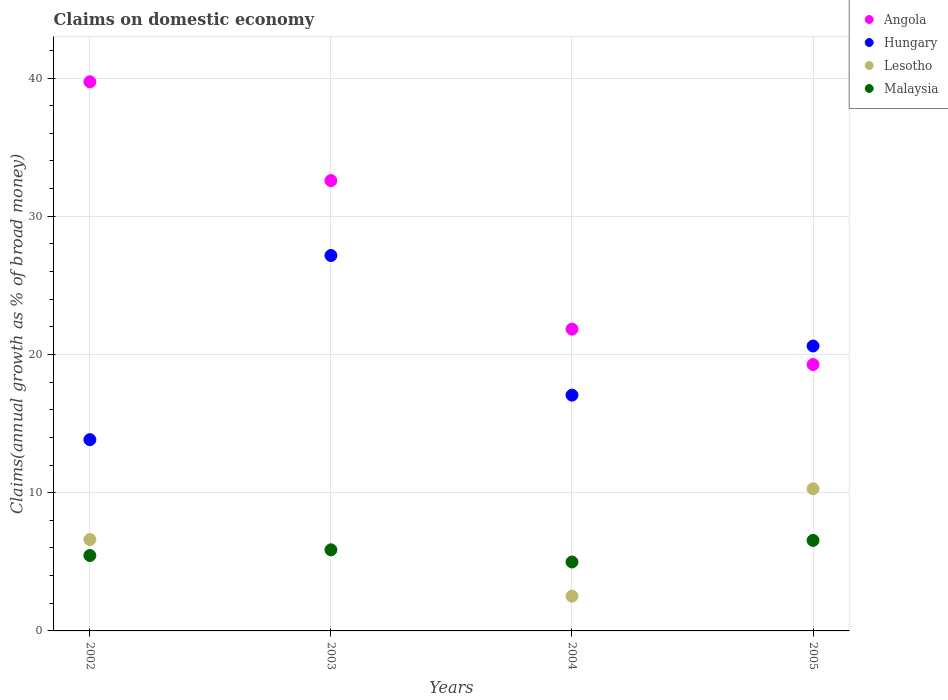Is the number of dotlines equal to the number of legend labels?
Keep it short and to the point. No. What is the percentage of broad money claimed on domestic economy in Angola in 2003?
Keep it short and to the point. 32.58. Across all years, what is the maximum percentage of broad money claimed on domestic economy in Lesotho?
Make the answer very short. 10.29. Across all years, what is the minimum percentage of broad money claimed on domestic economy in Angola?
Offer a very short reply. 19.27. What is the total percentage of broad money claimed on domestic economy in Malaysia in the graph?
Provide a succinct answer. 22.86. What is the difference between the percentage of broad money claimed on domestic economy in Angola in 2002 and that in 2004?
Offer a very short reply. 17.89. What is the difference between the percentage of broad money claimed on domestic economy in Hungary in 2002 and the percentage of broad money claimed on domestic economy in Lesotho in 2003?
Your response must be concise. 13.84. What is the average percentage of broad money claimed on domestic economy in Hungary per year?
Give a very brief answer. 19.67. In the year 2002, what is the difference between the percentage of broad money claimed on domestic economy in Lesotho and percentage of broad money claimed on domestic economy in Angola?
Provide a succinct answer. -33.12. In how many years, is the percentage of broad money claimed on domestic economy in Lesotho greater than 36 %?
Ensure brevity in your answer.  0. What is the ratio of the percentage of broad money claimed on domestic economy in Hungary in 2002 to that in 2005?
Make the answer very short. 0.67. Is the difference between the percentage of broad money claimed on domestic economy in Lesotho in 2002 and 2004 greater than the difference between the percentage of broad money claimed on domestic economy in Angola in 2002 and 2004?
Offer a very short reply. No. What is the difference between the highest and the second highest percentage of broad money claimed on domestic economy in Malaysia?
Offer a terse response. 0.68. What is the difference between the highest and the lowest percentage of broad money claimed on domestic economy in Lesotho?
Your answer should be compact. 10.29. Is it the case that in every year, the sum of the percentage of broad money claimed on domestic economy in Hungary and percentage of broad money claimed on domestic economy in Angola  is greater than the sum of percentage of broad money claimed on domestic economy in Lesotho and percentage of broad money claimed on domestic economy in Malaysia?
Give a very brief answer. No. Is it the case that in every year, the sum of the percentage of broad money claimed on domestic economy in Angola and percentage of broad money claimed on domestic economy in Lesotho  is greater than the percentage of broad money claimed on domestic economy in Hungary?
Give a very brief answer. Yes. Does the percentage of broad money claimed on domestic economy in Angola monotonically increase over the years?
Ensure brevity in your answer.  No. Is the percentage of broad money claimed on domestic economy in Hungary strictly greater than the percentage of broad money claimed on domestic economy in Angola over the years?
Your response must be concise. No. Is the percentage of broad money claimed on domestic economy in Hungary strictly less than the percentage of broad money claimed on domestic economy in Angola over the years?
Provide a short and direct response. No. How many dotlines are there?
Your answer should be compact. 4. How many years are there in the graph?
Provide a succinct answer. 4. How are the legend labels stacked?
Keep it short and to the point. Vertical. What is the title of the graph?
Provide a succinct answer. Claims on domestic economy. What is the label or title of the X-axis?
Offer a terse response. Years. What is the label or title of the Y-axis?
Make the answer very short. Claims(annual growth as % of broad money). What is the Claims(annual growth as % of broad money) in Angola in 2002?
Your answer should be compact. 39.73. What is the Claims(annual growth as % of broad money) of Hungary in 2002?
Provide a succinct answer. 13.84. What is the Claims(annual growth as % of broad money) of Lesotho in 2002?
Ensure brevity in your answer.  6.61. What is the Claims(annual growth as % of broad money) in Malaysia in 2002?
Make the answer very short. 5.45. What is the Claims(annual growth as % of broad money) of Angola in 2003?
Keep it short and to the point. 32.58. What is the Claims(annual growth as % of broad money) in Hungary in 2003?
Provide a short and direct response. 27.16. What is the Claims(annual growth as % of broad money) of Malaysia in 2003?
Offer a terse response. 5.87. What is the Claims(annual growth as % of broad money) of Angola in 2004?
Provide a succinct answer. 21.83. What is the Claims(annual growth as % of broad money) in Hungary in 2004?
Keep it short and to the point. 17.06. What is the Claims(annual growth as % of broad money) in Lesotho in 2004?
Your answer should be very brief. 2.51. What is the Claims(annual growth as % of broad money) in Malaysia in 2004?
Your response must be concise. 4.99. What is the Claims(annual growth as % of broad money) in Angola in 2005?
Ensure brevity in your answer.  19.27. What is the Claims(annual growth as % of broad money) of Hungary in 2005?
Provide a short and direct response. 20.61. What is the Claims(annual growth as % of broad money) of Lesotho in 2005?
Provide a short and direct response. 10.29. What is the Claims(annual growth as % of broad money) of Malaysia in 2005?
Provide a short and direct response. 6.55. Across all years, what is the maximum Claims(annual growth as % of broad money) of Angola?
Keep it short and to the point. 39.73. Across all years, what is the maximum Claims(annual growth as % of broad money) in Hungary?
Make the answer very short. 27.16. Across all years, what is the maximum Claims(annual growth as % of broad money) of Lesotho?
Give a very brief answer. 10.29. Across all years, what is the maximum Claims(annual growth as % of broad money) in Malaysia?
Make the answer very short. 6.55. Across all years, what is the minimum Claims(annual growth as % of broad money) of Angola?
Keep it short and to the point. 19.27. Across all years, what is the minimum Claims(annual growth as % of broad money) in Hungary?
Offer a very short reply. 13.84. Across all years, what is the minimum Claims(annual growth as % of broad money) of Malaysia?
Your response must be concise. 4.99. What is the total Claims(annual growth as % of broad money) in Angola in the graph?
Keep it short and to the point. 113.41. What is the total Claims(annual growth as % of broad money) in Hungary in the graph?
Your answer should be very brief. 78.67. What is the total Claims(annual growth as % of broad money) in Lesotho in the graph?
Your answer should be very brief. 19.41. What is the total Claims(annual growth as % of broad money) of Malaysia in the graph?
Keep it short and to the point. 22.86. What is the difference between the Claims(annual growth as % of broad money) in Angola in 2002 and that in 2003?
Ensure brevity in your answer.  7.15. What is the difference between the Claims(annual growth as % of broad money) of Hungary in 2002 and that in 2003?
Make the answer very short. -13.32. What is the difference between the Claims(annual growth as % of broad money) of Malaysia in 2002 and that in 2003?
Ensure brevity in your answer.  -0.41. What is the difference between the Claims(annual growth as % of broad money) in Angola in 2002 and that in 2004?
Make the answer very short. 17.89. What is the difference between the Claims(annual growth as % of broad money) in Hungary in 2002 and that in 2004?
Offer a very short reply. -3.22. What is the difference between the Claims(annual growth as % of broad money) of Lesotho in 2002 and that in 2004?
Offer a very short reply. 4.1. What is the difference between the Claims(annual growth as % of broad money) of Malaysia in 2002 and that in 2004?
Make the answer very short. 0.47. What is the difference between the Claims(annual growth as % of broad money) of Angola in 2002 and that in 2005?
Offer a very short reply. 20.45. What is the difference between the Claims(annual growth as % of broad money) in Hungary in 2002 and that in 2005?
Your answer should be very brief. -6.78. What is the difference between the Claims(annual growth as % of broad money) of Lesotho in 2002 and that in 2005?
Offer a terse response. -3.68. What is the difference between the Claims(annual growth as % of broad money) in Malaysia in 2002 and that in 2005?
Offer a very short reply. -1.09. What is the difference between the Claims(annual growth as % of broad money) in Angola in 2003 and that in 2004?
Make the answer very short. 10.75. What is the difference between the Claims(annual growth as % of broad money) of Hungary in 2003 and that in 2004?
Make the answer very short. 10.1. What is the difference between the Claims(annual growth as % of broad money) in Malaysia in 2003 and that in 2004?
Ensure brevity in your answer.  0.88. What is the difference between the Claims(annual growth as % of broad money) of Angola in 2003 and that in 2005?
Your response must be concise. 13.31. What is the difference between the Claims(annual growth as % of broad money) in Hungary in 2003 and that in 2005?
Keep it short and to the point. 6.55. What is the difference between the Claims(annual growth as % of broad money) in Malaysia in 2003 and that in 2005?
Offer a terse response. -0.68. What is the difference between the Claims(annual growth as % of broad money) of Angola in 2004 and that in 2005?
Give a very brief answer. 2.56. What is the difference between the Claims(annual growth as % of broad money) of Hungary in 2004 and that in 2005?
Keep it short and to the point. -3.56. What is the difference between the Claims(annual growth as % of broad money) in Lesotho in 2004 and that in 2005?
Provide a short and direct response. -7.77. What is the difference between the Claims(annual growth as % of broad money) of Malaysia in 2004 and that in 2005?
Offer a very short reply. -1.56. What is the difference between the Claims(annual growth as % of broad money) of Angola in 2002 and the Claims(annual growth as % of broad money) of Hungary in 2003?
Your answer should be very brief. 12.57. What is the difference between the Claims(annual growth as % of broad money) in Angola in 2002 and the Claims(annual growth as % of broad money) in Malaysia in 2003?
Provide a short and direct response. 33.86. What is the difference between the Claims(annual growth as % of broad money) in Hungary in 2002 and the Claims(annual growth as % of broad money) in Malaysia in 2003?
Ensure brevity in your answer.  7.97. What is the difference between the Claims(annual growth as % of broad money) of Lesotho in 2002 and the Claims(annual growth as % of broad money) of Malaysia in 2003?
Keep it short and to the point. 0.74. What is the difference between the Claims(annual growth as % of broad money) in Angola in 2002 and the Claims(annual growth as % of broad money) in Hungary in 2004?
Ensure brevity in your answer.  22.67. What is the difference between the Claims(annual growth as % of broad money) in Angola in 2002 and the Claims(annual growth as % of broad money) in Lesotho in 2004?
Give a very brief answer. 37.21. What is the difference between the Claims(annual growth as % of broad money) of Angola in 2002 and the Claims(annual growth as % of broad money) of Malaysia in 2004?
Your answer should be compact. 34.74. What is the difference between the Claims(annual growth as % of broad money) of Hungary in 2002 and the Claims(annual growth as % of broad money) of Lesotho in 2004?
Provide a succinct answer. 11.33. What is the difference between the Claims(annual growth as % of broad money) in Hungary in 2002 and the Claims(annual growth as % of broad money) in Malaysia in 2004?
Give a very brief answer. 8.85. What is the difference between the Claims(annual growth as % of broad money) in Lesotho in 2002 and the Claims(annual growth as % of broad money) in Malaysia in 2004?
Provide a succinct answer. 1.62. What is the difference between the Claims(annual growth as % of broad money) of Angola in 2002 and the Claims(annual growth as % of broad money) of Hungary in 2005?
Ensure brevity in your answer.  19.11. What is the difference between the Claims(annual growth as % of broad money) of Angola in 2002 and the Claims(annual growth as % of broad money) of Lesotho in 2005?
Make the answer very short. 29.44. What is the difference between the Claims(annual growth as % of broad money) in Angola in 2002 and the Claims(annual growth as % of broad money) in Malaysia in 2005?
Offer a very short reply. 33.18. What is the difference between the Claims(annual growth as % of broad money) in Hungary in 2002 and the Claims(annual growth as % of broad money) in Lesotho in 2005?
Your answer should be very brief. 3.55. What is the difference between the Claims(annual growth as % of broad money) in Hungary in 2002 and the Claims(annual growth as % of broad money) in Malaysia in 2005?
Your answer should be compact. 7.29. What is the difference between the Claims(annual growth as % of broad money) in Lesotho in 2002 and the Claims(annual growth as % of broad money) in Malaysia in 2005?
Ensure brevity in your answer.  0.06. What is the difference between the Claims(annual growth as % of broad money) of Angola in 2003 and the Claims(annual growth as % of broad money) of Hungary in 2004?
Keep it short and to the point. 15.52. What is the difference between the Claims(annual growth as % of broad money) of Angola in 2003 and the Claims(annual growth as % of broad money) of Lesotho in 2004?
Keep it short and to the point. 30.07. What is the difference between the Claims(annual growth as % of broad money) of Angola in 2003 and the Claims(annual growth as % of broad money) of Malaysia in 2004?
Your answer should be compact. 27.59. What is the difference between the Claims(annual growth as % of broad money) of Hungary in 2003 and the Claims(annual growth as % of broad money) of Lesotho in 2004?
Offer a very short reply. 24.65. What is the difference between the Claims(annual growth as % of broad money) in Hungary in 2003 and the Claims(annual growth as % of broad money) in Malaysia in 2004?
Your response must be concise. 22.17. What is the difference between the Claims(annual growth as % of broad money) of Angola in 2003 and the Claims(annual growth as % of broad money) of Hungary in 2005?
Offer a very short reply. 11.97. What is the difference between the Claims(annual growth as % of broad money) in Angola in 2003 and the Claims(annual growth as % of broad money) in Lesotho in 2005?
Offer a terse response. 22.29. What is the difference between the Claims(annual growth as % of broad money) of Angola in 2003 and the Claims(annual growth as % of broad money) of Malaysia in 2005?
Keep it short and to the point. 26.03. What is the difference between the Claims(annual growth as % of broad money) in Hungary in 2003 and the Claims(annual growth as % of broad money) in Lesotho in 2005?
Provide a short and direct response. 16.87. What is the difference between the Claims(annual growth as % of broad money) of Hungary in 2003 and the Claims(annual growth as % of broad money) of Malaysia in 2005?
Provide a short and direct response. 20.61. What is the difference between the Claims(annual growth as % of broad money) in Angola in 2004 and the Claims(annual growth as % of broad money) in Hungary in 2005?
Keep it short and to the point. 1.22. What is the difference between the Claims(annual growth as % of broad money) of Angola in 2004 and the Claims(annual growth as % of broad money) of Lesotho in 2005?
Give a very brief answer. 11.55. What is the difference between the Claims(annual growth as % of broad money) in Angola in 2004 and the Claims(annual growth as % of broad money) in Malaysia in 2005?
Offer a very short reply. 15.28. What is the difference between the Claims(annual growth as % of broad money) in Hungary in 2004 and the Claims(annual growth as % of broad money) in Lesotho in 2005?
Offer a very short reply. 6.77. What is the difference between the Claims(annual growth as % of broad money) in Hungary in 2004 and the Claims(annual growth as % of broad money) in Malaysia in 2005?
Offer a very short reply. 10.51. What is the difference between the Claims(annual growth as % of broad money) of Lesotho in 2004 and the Claims(annual growth as % of broad money) of Malaysia in 2005?
Your answer should be very brief. -4.04. What is the average Claims(annual growth as % of broad money) in Angola per year?
Provide a succinct answer. 28.35. What is the average Claims(annual growth as % of broad money) of Hungary per year?
Provide a short and direct response. 19.67. What is the average Claims(annual growth as % of broad money) in Lesotho per year?
Offer a very short reply. 4.85. What is the average Claims(annual growth as % of broad money) of Malaysia per year?
Your answer should be compact. 5.71. In the year 2002, what is the difference between the Claims(annual growth as % of broad money) in Angola and Claims(annual growth as % of broad money) in Hungary?
Keep it short and to the point. 25.89. In the year 2002, what is the difference between the Claims(annual growth as % of broad money) in Angola and Claims(annual growth as % of broad money) in Lesotho?
Keep it short and to the point. 33.12. In the year 2002, what is the difference between the Claims(annual growth as % of broad money) in Angola and Claims(annual growth as % of broad money) in Malaysia?
Offer a very short reply. 34.27. In the year 2002, what is the difference between the Claims(annual growth as % of broad money) of Hungary and Claims(annual growth as % of broad money) of Lesotho?
Offer a terse response. 7.23. In the year 2002, what is the difference between the Claims(annual growth as % of broad money) of Hungary and Claims(annual growth as % of broad money) of Malaysia?
Offer a very short reply. 8.38. In the year 2002, what is the difference between the Claims(annual growth as % of broad money) of Lesotho and Claims(annual growth as % of broad money) of Malaysia?
Give a very brief answer. 1.16. In the year 2003, what is the difference between the Claims(annual growth as % of broad money) of Angola and Claims(annual growth as % of broad money) of Hungary?
Your response must be concise. 5.42. In the year 2003, what is the difference between the Claims(annual growth as % of broad money) of Angola and Claims(annual growth as % of broad money) of Malaysia?
Offer a terse response. 26.71. In the year 2003, what is the difference between the Claims(annual growth as % of broad money) in Hungary and Claims(annual growth as % of broad money) in Malaysia?
Your response must be concise. 21.29. In the year 2004, what is the difference between the Claims(annual growth as % of broad money) in Angola and Claims(annual growth as % of broad money) in Hungary?
Provide a short and direct response. 4.77. In the year 2004, what is the difference between the Claims(annual growth as % of broad money) in Angola and Claims(annual growth as % of broad money) in Lesotho?
Your answer should be very brief. 19.32. In the year 2004, what is the difference between the Claims(annual growth as % of broad money) in Angola and Claims(annual growth as % of broad money) in Malaysia?
Offer a very short reply. 16.85. In the year 2004, what is the difference between the Claims(annual growth as % of broad money) of Hungary and Claims(annual growth as % of broad money) of Lesotho?
Make the answer very short. 14.55. In the year 2004, what is the difference between the Claims(annual growth as % of broad money) in Hungary and Claims(annual growth as % of broad money) in Malaysia?
Offer a terse response. 12.07. In the year 2004, what is the difference between the Claims(annual growth as % of broad money) of Lesotho and Claims(annual growth as % of broad money) of Malaysia?
Ensure brevity in your answer.  -2.47. In the year 2005, what is the difference between the Claims(annual growth as % of broad money) in Angola and Claims(annual growth as % of broad money) in Hungary?
Make the answer very short. -1.34. In the year 2005, what is the difference between the Claims(annual growth as % of broad money) of Angola and Claims(annual growth as % of broad money) of Lesotho?
Your answer should be very brief. 8.99. In the year 2005, what is the difference between the Claims(annual growth as % of broad money) in Angola and Claims(annual growth as % of broad money) in Malaysia?
Keep it short and to the point. 12.72. In the year 2005, what is the difference between the Claims(annual growth as % of broad money) of Hungary and Claims(annual growth as % of broad money) of Lesotho?
Your response must be concise. 10.33. In the year 2005, what is the difference between the Claims(annual growth as % of broad money) of Hungary and Claims(annual growth as % of broad money) of Malaysia?
Keep it short and to the point. 14.07. In the year 2005, what is the difference between the Claims(annual growth as % of broad money) in Lesotho and Claims(annual growth as % of broad money) in Malaysia?
Your answer should be compact. 3.74. What is the ratio of the Claims(annual growth as % of broad money) in Angola in 2002 to that in 2003?
Your answer should be very brief. 1.22. What is the ratio of the Claims(annual growth as % of broad money) of Hungary in 2002 to that in 2003?
Your answer should be very brief. 0.51. What is the ratio of the Claims(annual growth as % of broad money) in Malaysia in 2002 to that in 2003?
Your answer should be very brief. 0.93. What is the ratio of the Claims(annual growth as % of broad money) of Angola in 2002 to that in 2004?
Make the answer very short. 1.82. What is the ratio of the Claims(annual growth as % of broad money) of Hungary in 2002 to that in 2004?
Your response must be concise. 0.81. What is the ratio of the Claims(annual growth as % of broad money) in Lesotho in 2002 to that in 2004?
Your answer should be compact. 2.63. What is the ratio of the Claims(annual growth as % of broad money) in Malaysia in 2002 to that in 2004?
Your response must be concise. 1.09. What is the ratio of the Claims(annual growth as % of broad money) in Angola in 2002 to that in 2005?
Your answer should be compact. 2.06. What is the ratio of the Claims(annual growth as % of broad money) in Hungary in 2002 to that in 2005?
Your answer should be compact. 0.67. What is the ratio of the Claims(annual growth as % of broad money) in Lesotho in 2002 to that in 2005?
Offer a terse response. 0.64. What is the ratio of the Claims(annual growth as % of broad money) of Malaysia in 2002 to that in 2005?
Ensure brevity in your answer.  0.83. What is the ratio of the Claims(annual growth as % of broad money) in Angola in 2003 to that in 2004?
Your response must be concise. 1.49. What is the ratio of the Claims(annual growth as % of broad money) in Hungary in 2003 to that in 2004?
Give a very brief answer. 1.59. What is the ratio of the Claims(annual growth as % of broad money) of Malaysia in 2003 to that in 2004?
Provide a succinct answer. 1.18. What is the ratio of the Claims(annual growth as % of broad money) in Angola in 2003 to that in 2005?
Provide a short and direct response. 1.69. What is the ratio of the Claims(annual growth as % of broad money) of Hungary in 2003 to that in 2005?
Give a very brief answer. 1.32. What is the ratio of the Claims(annual growth as % of broad money) of Malaysia in 2003 to that in 2005?
Make the answer very short. 0.9. What is the ratio of the Claims(annual growth as % of broad money) in Angola in 2004 to that in 2005?
Provide a succinct answer. 1.13. What is the ratio of the Claims(annual growth as % of broad money) of Hungary in 2004 to that in 2005?
Your answer should be very brief. 0.83. What is the ratio of the Claims(annual growth as % of broad money) in Lesotho in 2004 to that in 2005?
Provide a succinct answer. 0.24. What is the ratio of the Claims(annual growth as % of broad money) of Malaysia in 2004 to that in 2005?
Ensure brevity in your answer.  0.76. What is the difference between the highest and the second highest Claims(annual growth as % of broad money) in Angola?
Make the answer very short. 7.15. What is the difference between the highest and the second highest Claims(annual growth as % of broad money) of Hungary?
Offer a very short reply. 6.55. What is the difference between the highest and the second highest Claims(annual growth as % of broad money) of Lesotho?
Provide a short and direct response. 3.68. What is the difference between the highest and the second highest Claims(annual growth as % of broad money) in Malaysia?
Provide a short and direct response. 0.68. What is the difference between the highest and the lowest Claims(annual growth as % of broad money) of Angola?
Your answer should be compact. 20.45. What is the difference between the highest and the lowest Claims(annual growth as % of broad money) of Hungary?
Give a very brief answer. 13.32. What is the difference between the highest and the lowest Claims(annual growth as % of broad money) of Lesotho?
Provide a succinct answer. 10.29. What is the difference between the highest and the lowest Claims(annual growth as % of broad money) of Malaysia?
Provide a succinct answer. 1.56. 